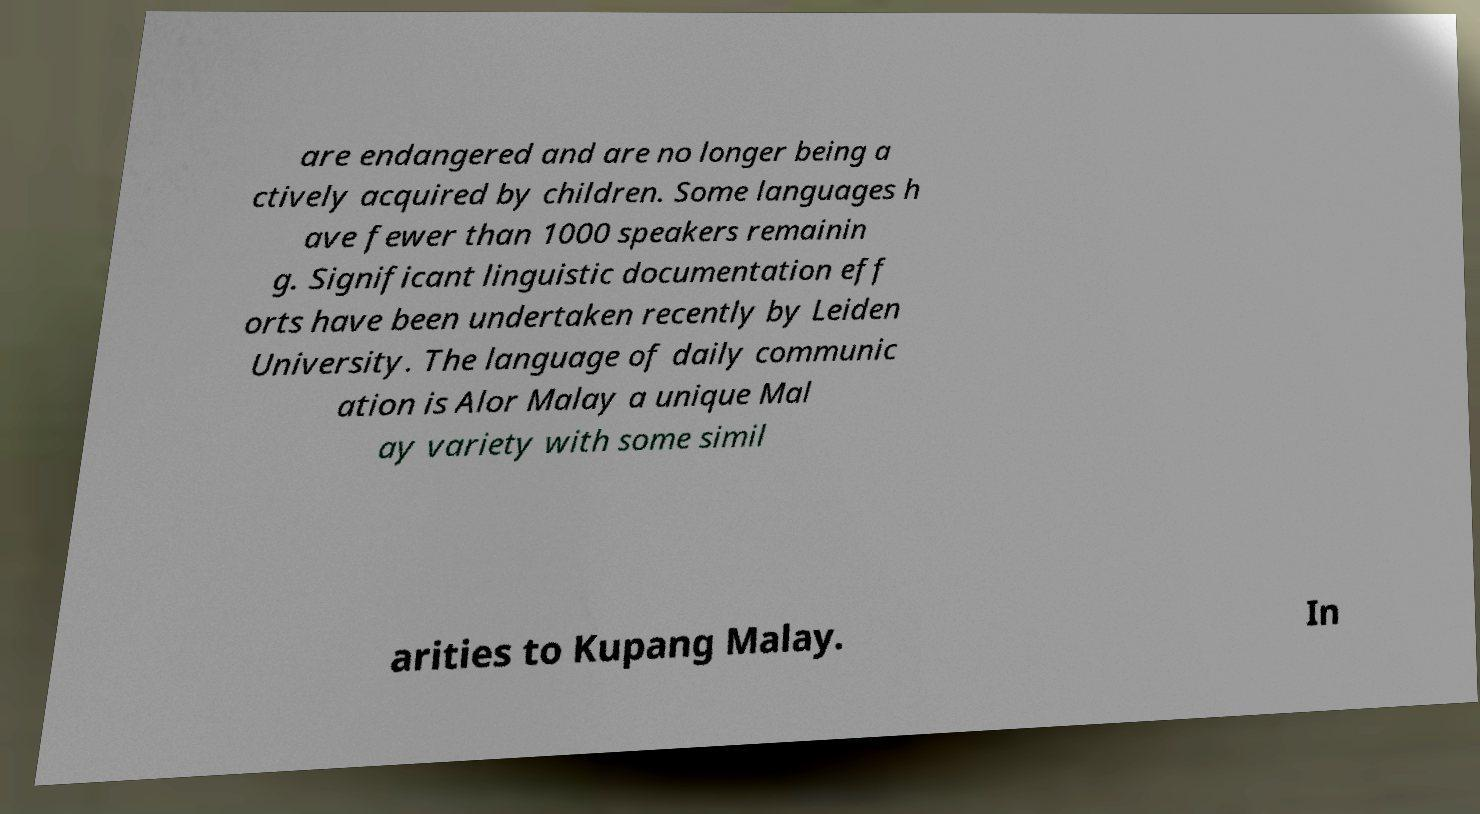For documentation purposes, I need the text within this image transcribed. Could you provide that? are endangered and are no longer being a ctively acquired by children. Some languages h ave fewer than 1000 speakers remainin g. Significant linguistic documentation eff orts have been undertaken recently by Leiden University. The language of daily communic ation is Alor Malay a unique Mal ay variety with some simil arities to Kupang Malay. In 